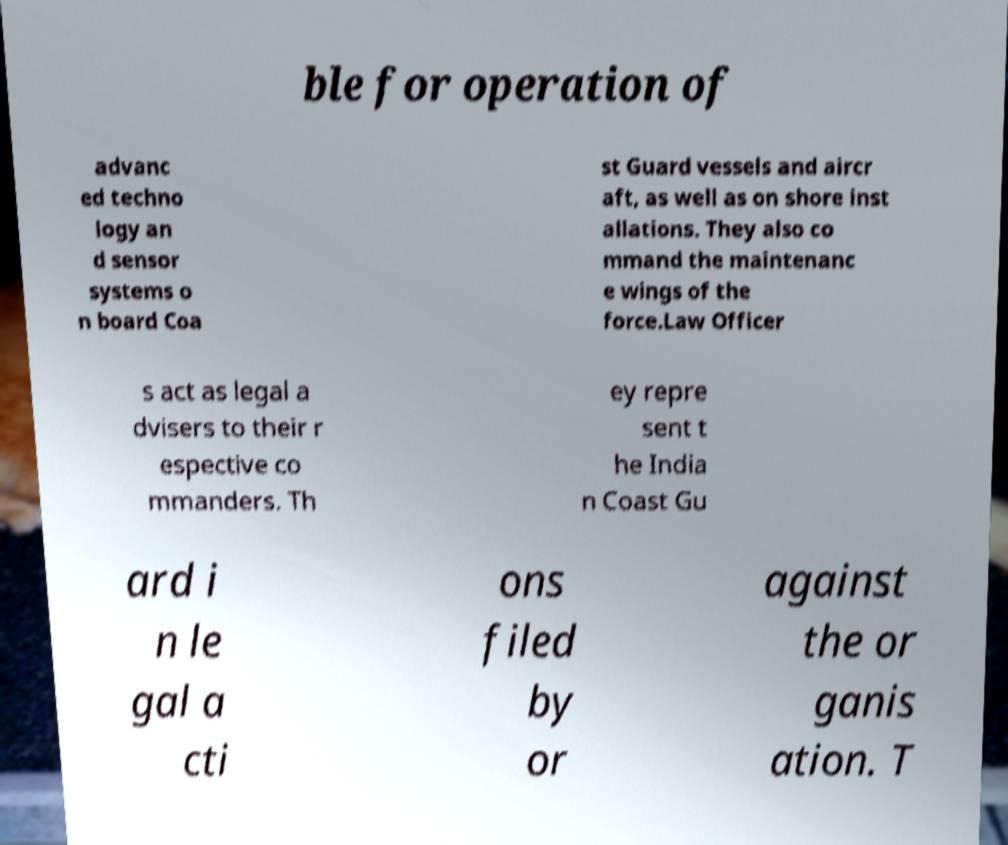Can you read and provide the text displayed in the image?This photo seems to have some interesting text. Can you extract and type it out for me? ble for operation of advanc ed techno logy an d sensor systems o n board Coa st Guard vessels and aircr aft, as well as on shore inst allations. They also co mmand the maintenanc e wings of the force.Law Officer s act as legal a dvisers to their r espective co mmanders. Th ey repre sent t he India n Coast Gu ard i n le gal a cti ons filed by or against the or ganis ation. T 